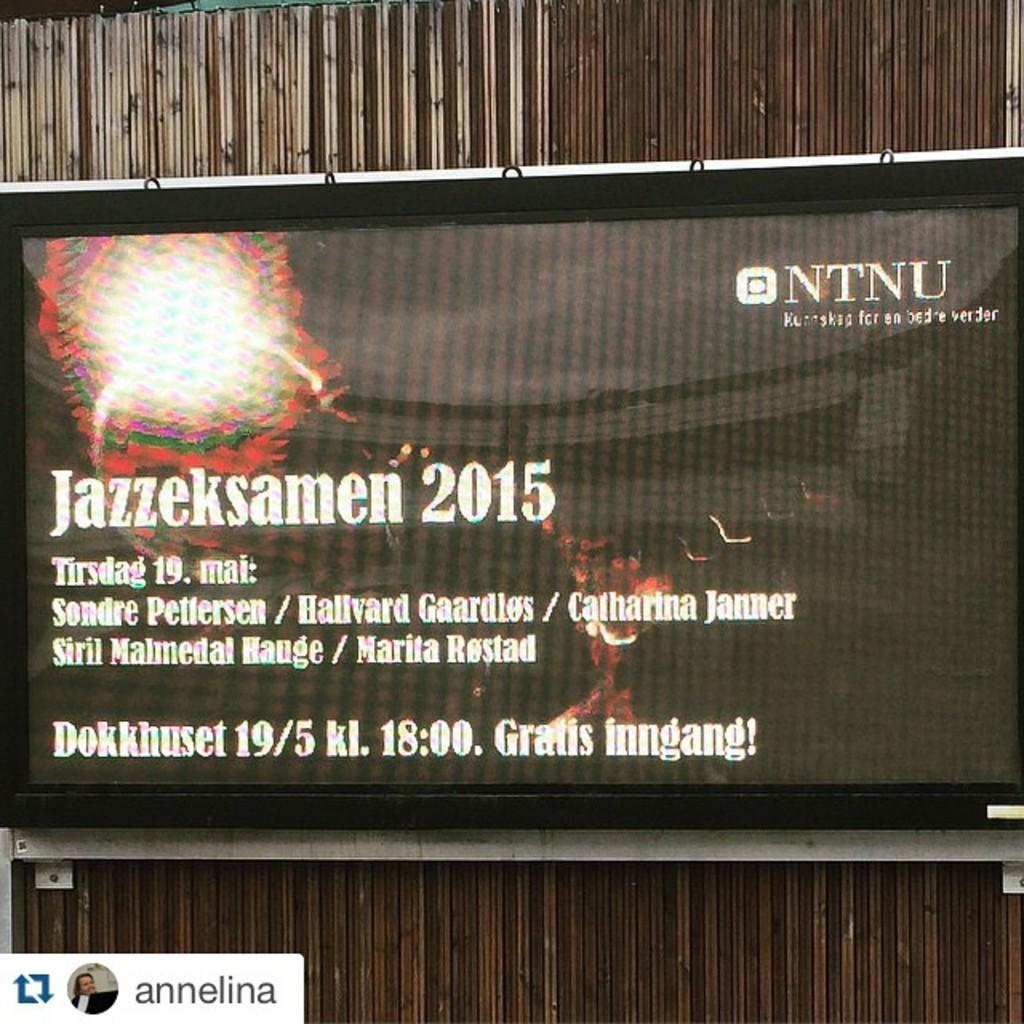<image>
Offer a succinct explanation of the picture presented. A sign says Jazzeksamen 2015 and NTNU on it. 